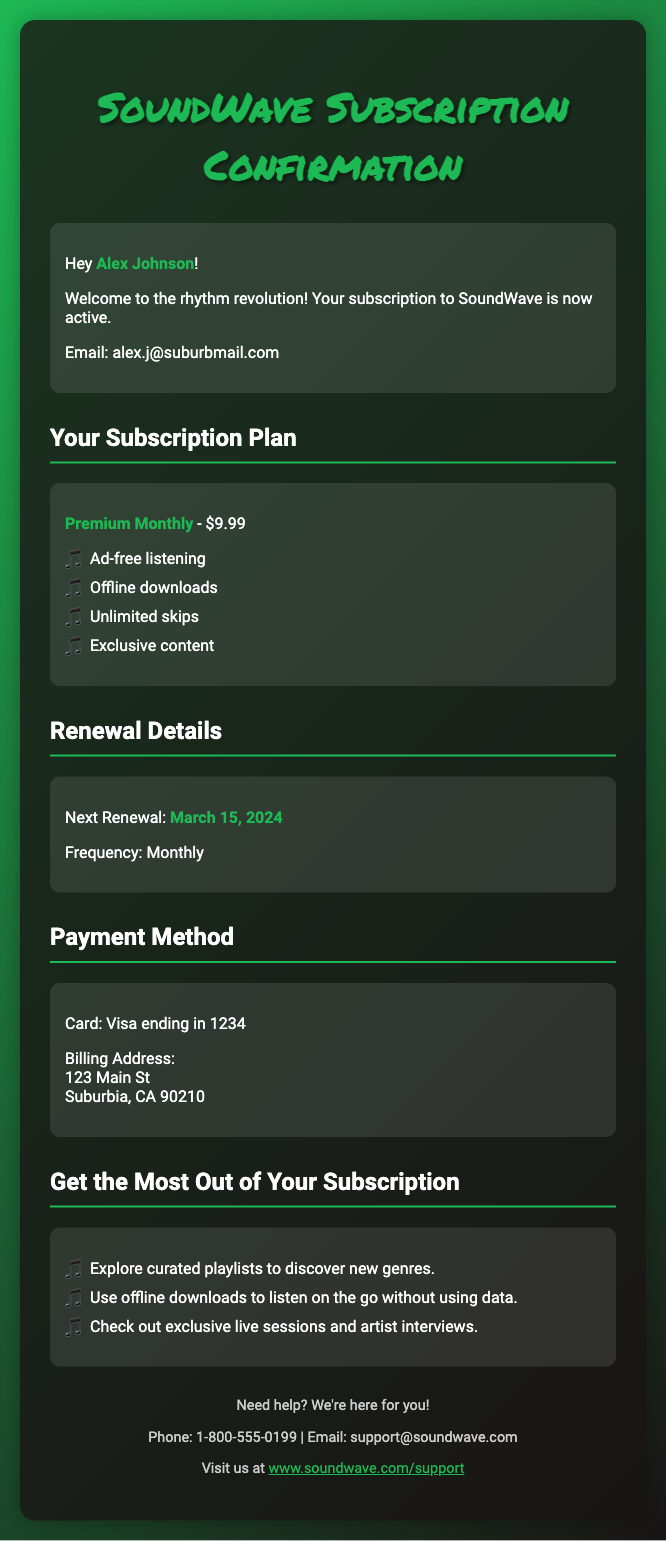what is the subscriber's name? The subscriber's name is mentioned in the greeting section, which is "Alex Johnson".
Answer: Alex Johnson what is the subscription plan? The subscription plan is specified in the plan details section, which is "Premium Monthly".
Answer: Premium Monthly how much does the subscription cost? The cost of the subscription is listed alongside the plan details, which is "$9.99".
Answer: $9.99 when is the next renewal date? The next renewal date is present in the renewal details section, which reads "March 15, 2024".
Answer: March 15, 2024 what payment method is used? The payment method is detailed in the payment method section, which indicates "Visa ending in 1234".
Answer: Visa ending in 1234 how often will the subscription renew? The frequency of renewal is stated in the renewal details, which is "Monthly".
Answer: Monthly what is one feature included in the subscription? The features of the subscription can be found in the feature list, where one example is "Ad-free listening".
Answer: Ad-free listening where is the billing address located? The billing address is provided in the payment method section, which includes "123 Main St, Suburbia, CA 90210".
Answer: 123 Main St, Suburbia, CA 90210 